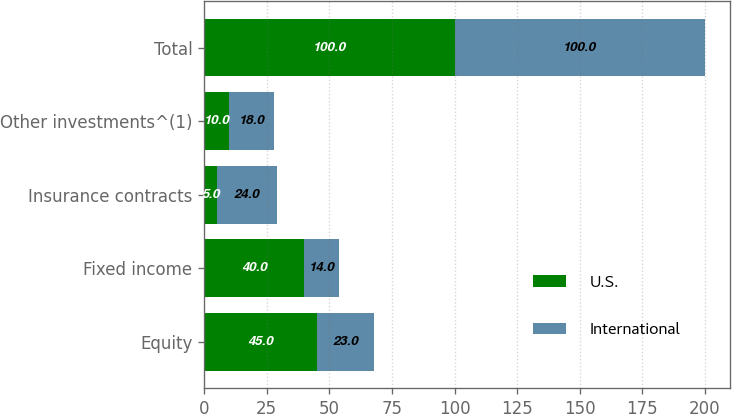Convert chart to OTSL. <chart><loc_0><loc_0><loc_500><loc_500><stacked_bar_chart><ecel><fcel>Equity<fcel>Fixed income<fcel>Insurance contracts<fcel>Other investments^(1)<fcel>Total<nl><fcel>U.S.<fcel>45<fcel>40<fcel>5<fcel>10<fcel>100<nl><fcel>International<fcel>23<fcel>14<fcel>24<fcel>18<fcel>100<nl></chart> 